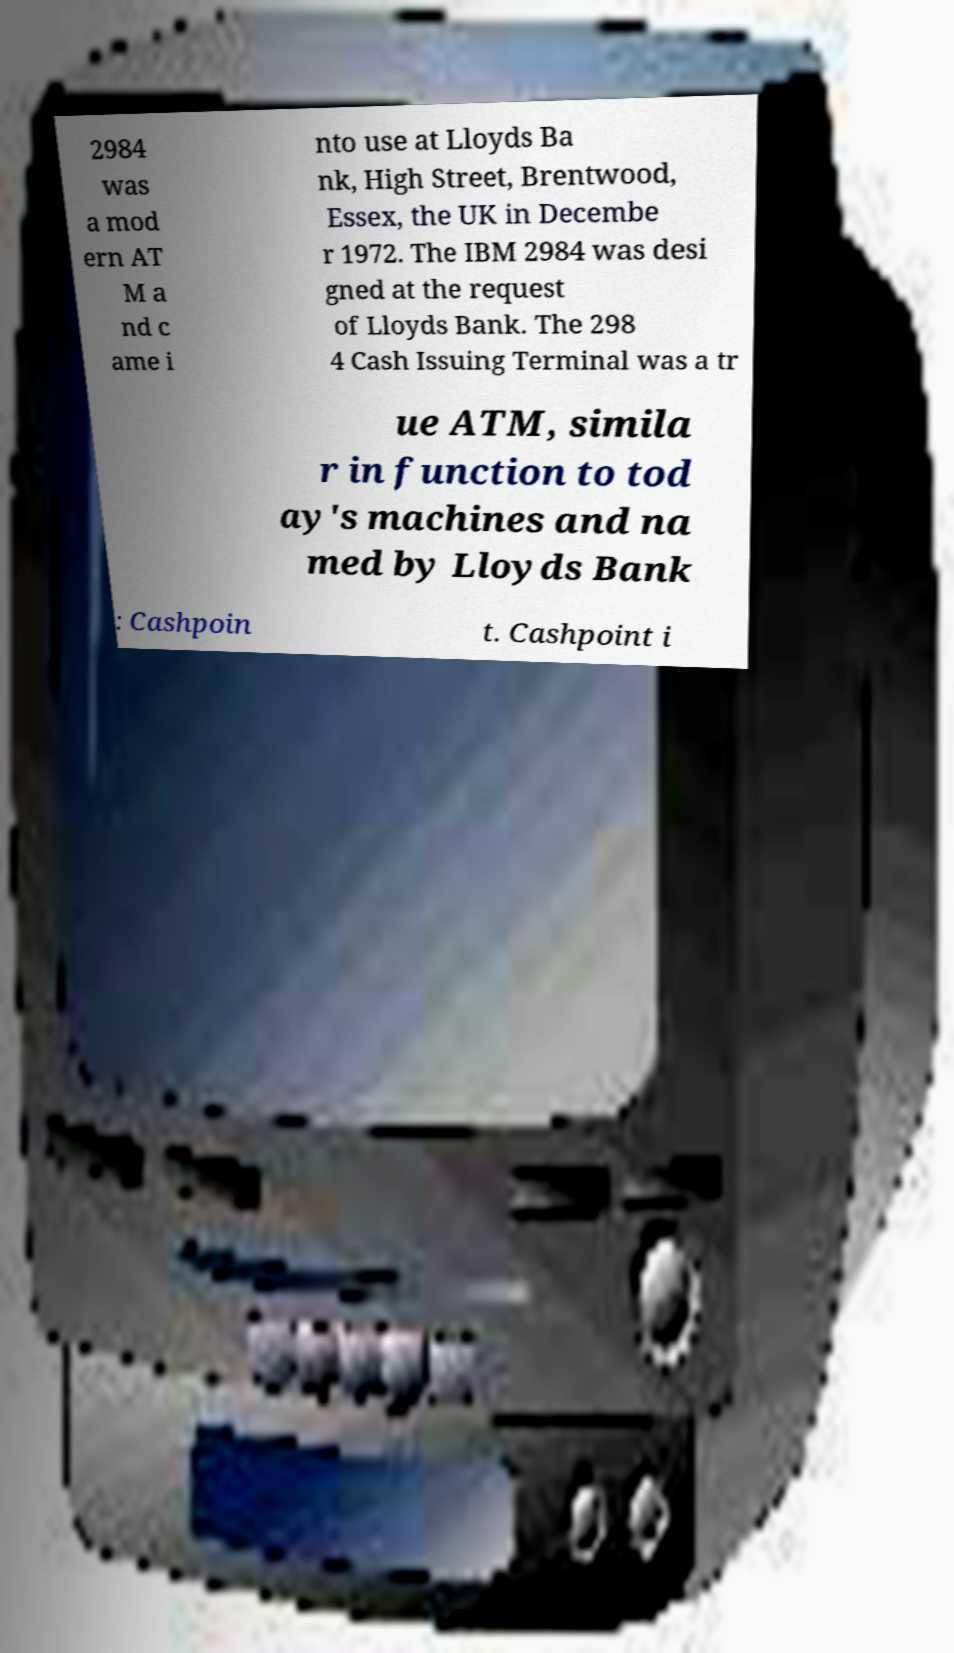Could you extract and type out the text from this image? 2984 was a mod ern AT M a nd c ame i nto use at Lloyds Ba nk, High Street, Brentwood, Essex, the UK in Decembe r 1972. The IBM 2984 was desi gned at the request of Lloyds Bank. The 298 4 Cash Issuing Terminal was a tr ue ATM, simila r in function to tod ay's machines and na med by Lloyds Bank : Cashpoin t. Cashpoint i 